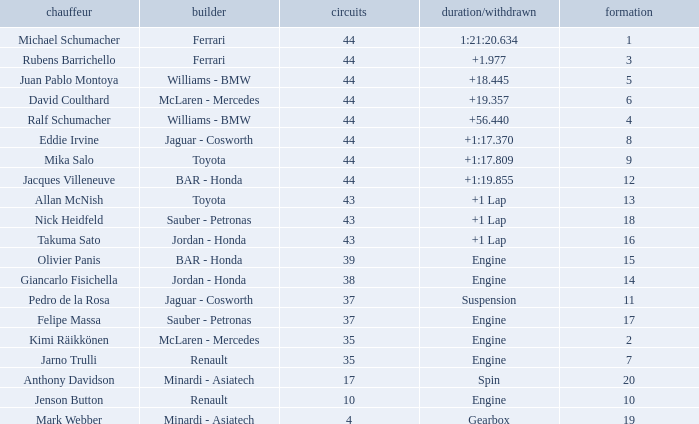Can you parse all the data within this table? {'header': ['chauffeur', 'builder', 'circuits', 'duration/withdrawn', 'formation'], 'rows': [['Michael Schumacher', 'Ferrari', '44', '1:21:20.634', '1'], ['Rubens Barrichello', 'Ferrari', '44', '+1.977', '3'], ['Juan Pablo Montoya', 'Williams - BMW', '44', '+18.445', '5'], ['David Coulthard', 'McLaren - Mercedes', '44', '+19.357', '6'], ['Ralf Schumacher', 'Williams - BMW', '44', '+56.440', '4'], ['Eddie Irvine', 'Jaguar - Cosworth', '44', '+1:17.370', '8'], ['Mika Salo', 'Toyota', '44', '+1:17.809', '9'], ['Jacques Villeneuve', 'BAR - Honda', '44', '+1:19.855', '12'], ['Allan McNish', 'Toyota', '43', '+1 Lap', '13'], ['Nick Heidfeld', 'Sauber - Petronas', '43', '+1 Lap', '18'], ['Takuma Sato', 'Jordan - Honda', '43', '+1 Lap', '16'], ['Olivier Panis', 'BAR - Honda', '39', 'Engine', '15'], ['Giancarlo Fisichella', 'Jordan - Honda', '38', 'Engine', '14'], ['Pedro de la Rosa', 'Jaguar - Cosworth', '37', 'Suspension', '11'], ['Felipe Massa', 'Sauber - Petronas', '37', 'Engine', '17'], ['Kimi Räikkönen', 'McLaren - Mercedes', '35', 'Engine', '2'], ['Jarno Trulli', 'Renault', '35', 'Engine', '7'], ['Anthony Davidson', 'Minardi - Asiatech', '17', 'Spin', '20'], ['Jenson Button', 'Renault', '10', 'Engine', '10'], ['Mark Webber', 'Minardi - Asiatech', '4', 'Gearbox', '19']]} What was the fewest laps for somone who finished +18.445? 44.0. 